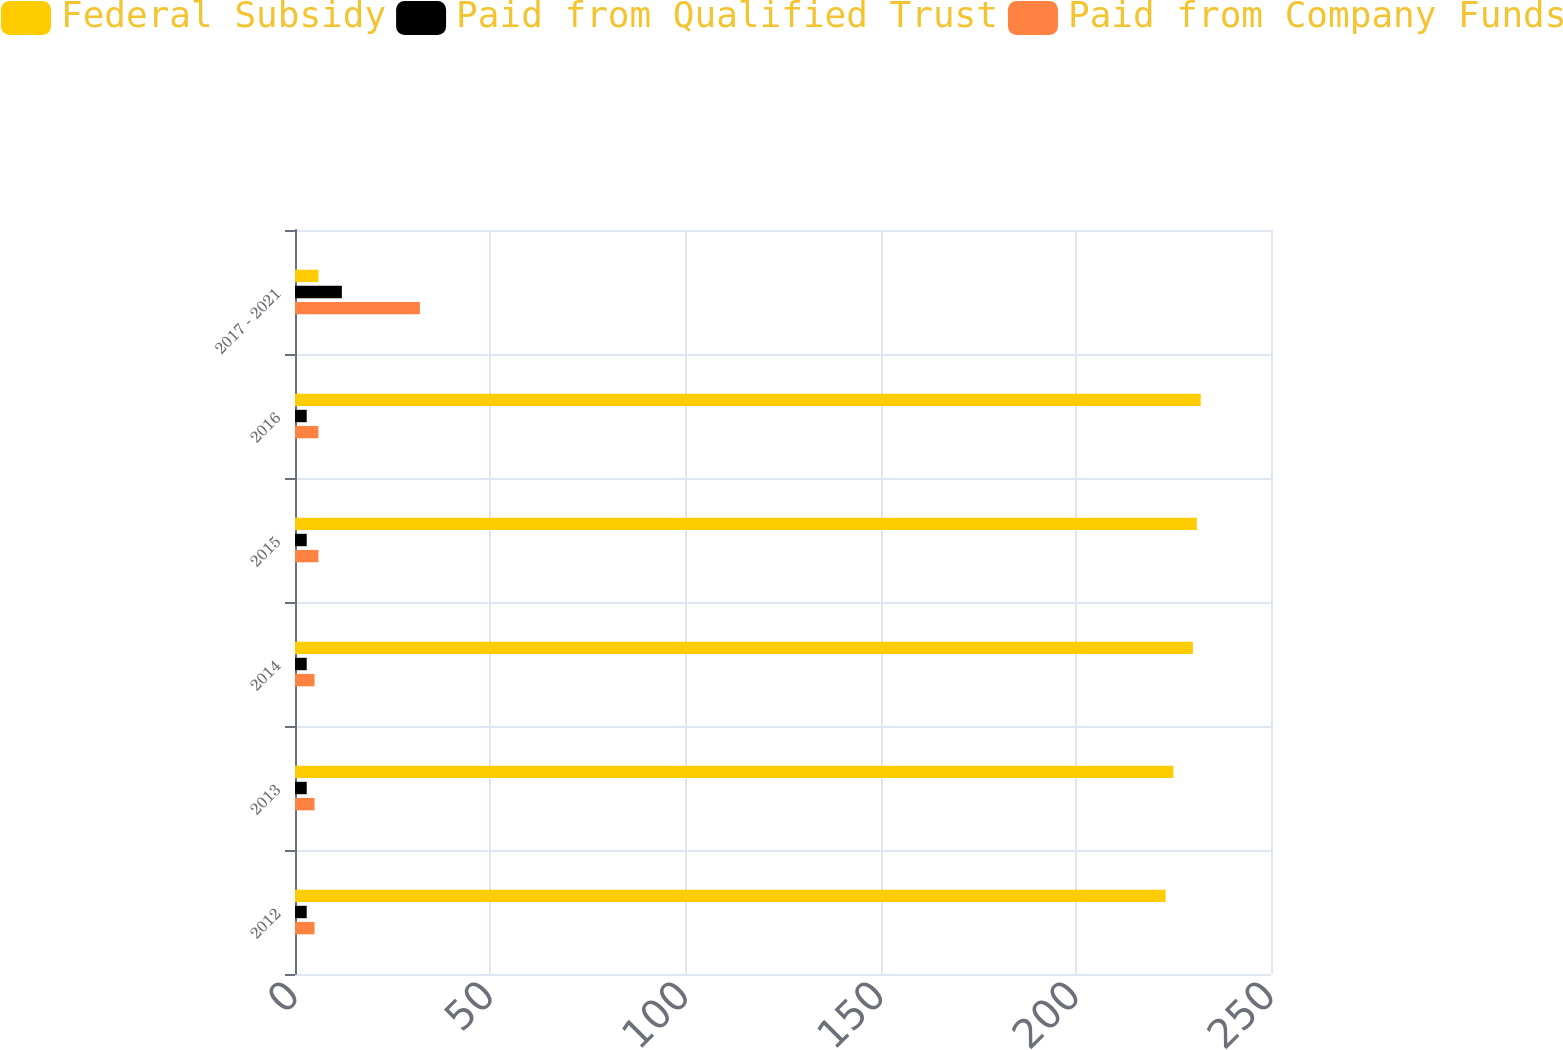Convert chart to OTSL. <chart><loc_0><loc_0><loc_500><loc_500><stacked_bar_chart><ecel><fcel>2012<fcel>2013<fcel>2014<fcel>2015<fcel>2016<fcel>2017 - 2021<nl><fcel>Federal Subsidy<fcel>223<fcel>225<fcel>230<fcel>231<fcel>232<fcel>6<nl><fcel>Paid from Qualified Trust<fcel>3<fcel>3<fcel>3<fcel>3<fcel>3<fcel>12<nl><fcel>Paid from Company Funds<fcel>5<fcel>5<fcel>5<fcel>6<fcel>6<fcel>32<nl></chart> 